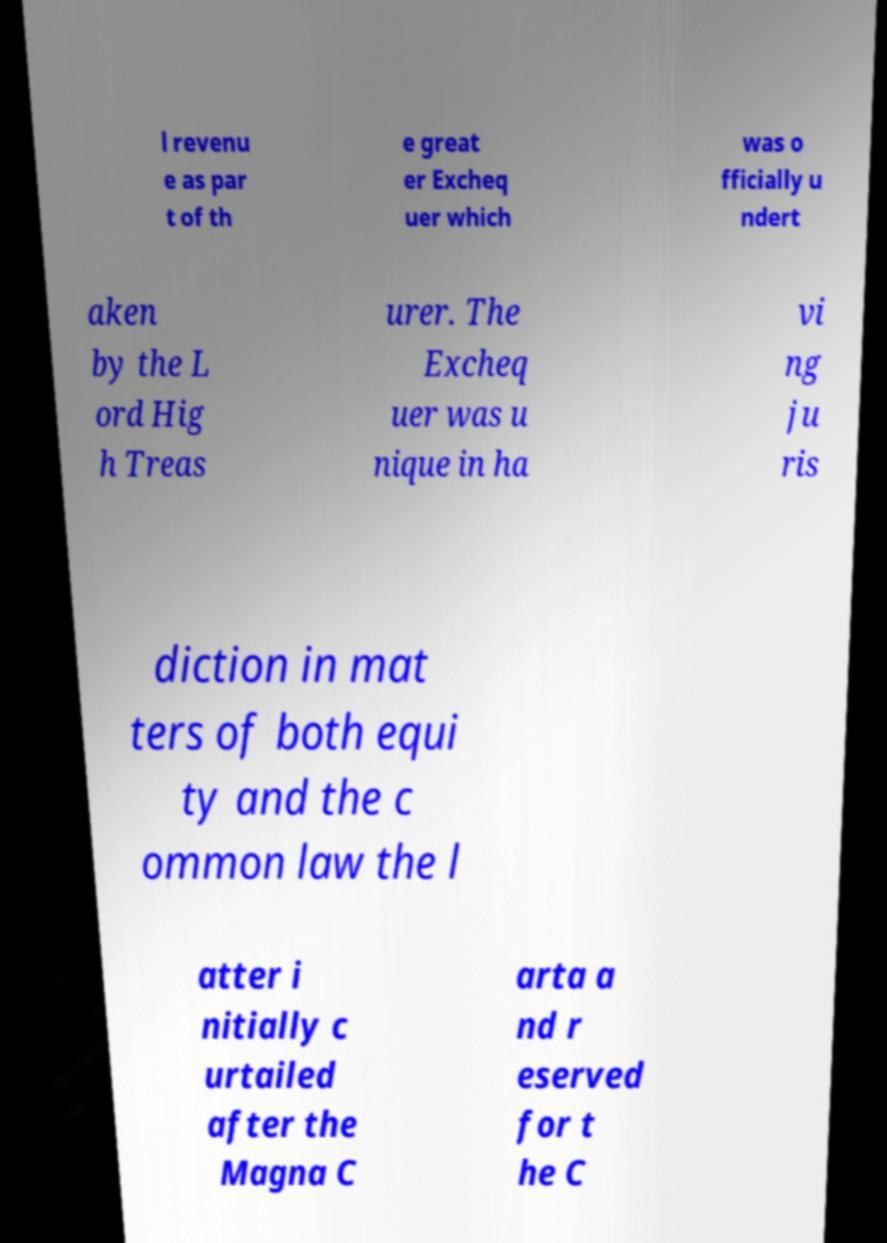Can you read and provide the text displayed in the image?This photo seems to have some interesting text. Can you extract and type it out for me? l revenu e as par t of th e great er Excheq uer which was o fficially u ndert aken by the L ord Hig h Treas urer. The Excheq uer was u nique in ha vi ng ju ris diction in mat ters of both equi ty and the c ommon law the l atter i nitially c urtailed after the Magna C arta a nd r eserved for t he C 